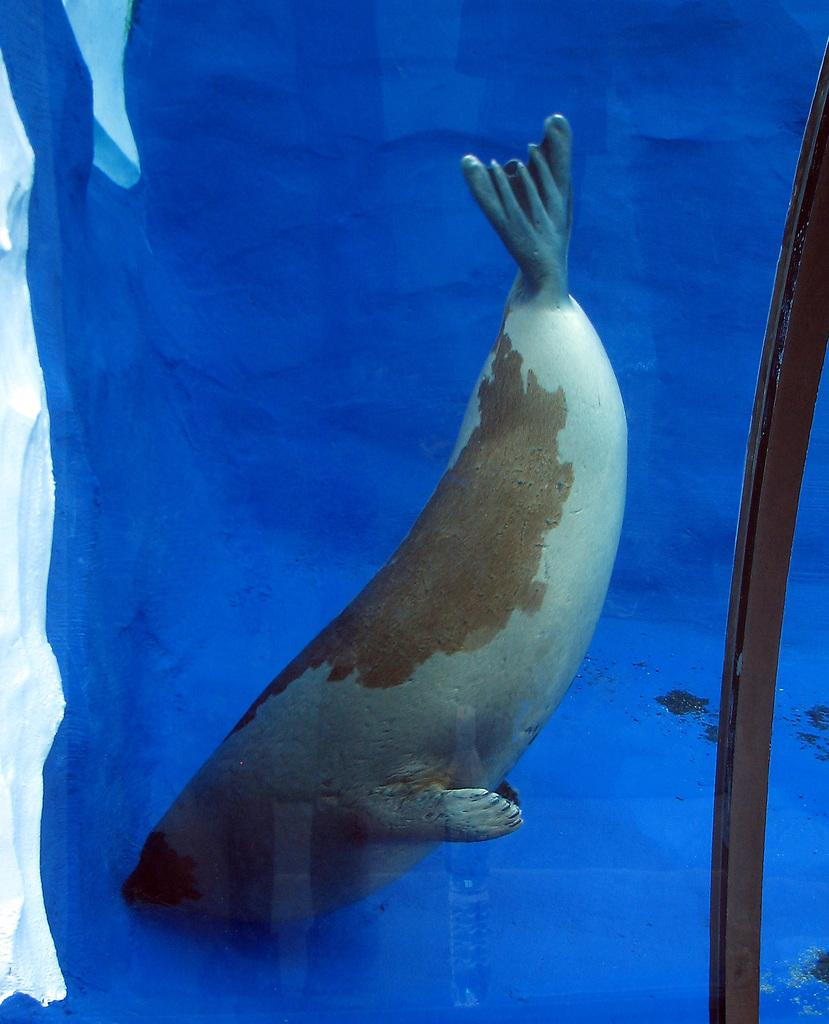What type of artwork is depicted in the image? The image is a painting. What is the main subject of the painting? There is a whale in the center of the image. What color is the background of the painting? The background of the image is blue in color. What team is the whale a part of in the image? There is no team or any indication of a team in the image; it is a painting of a whale in a blue background. 